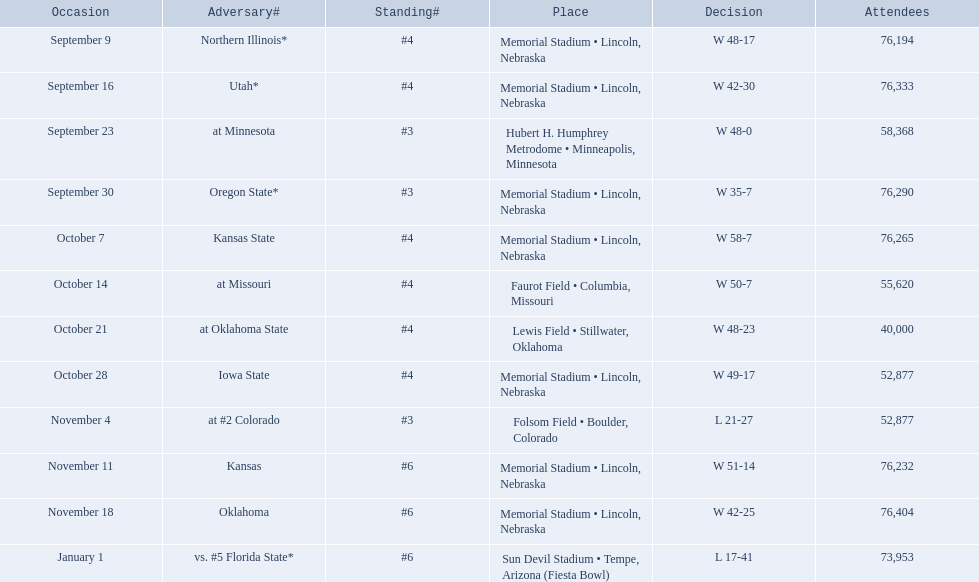Which opponenets did the nebraska cornhuskers score fewer than 40 points against? Oregon State*, at #2 Colorado, vs. #5 Florida State*. Of these games, which ones had an attendance of greater than 70,000? Oregon State*, vs. #5 Florida State*. Which of these opponents did they beat? Oregon State*. How many people were in attendance at that game? 76,290. 